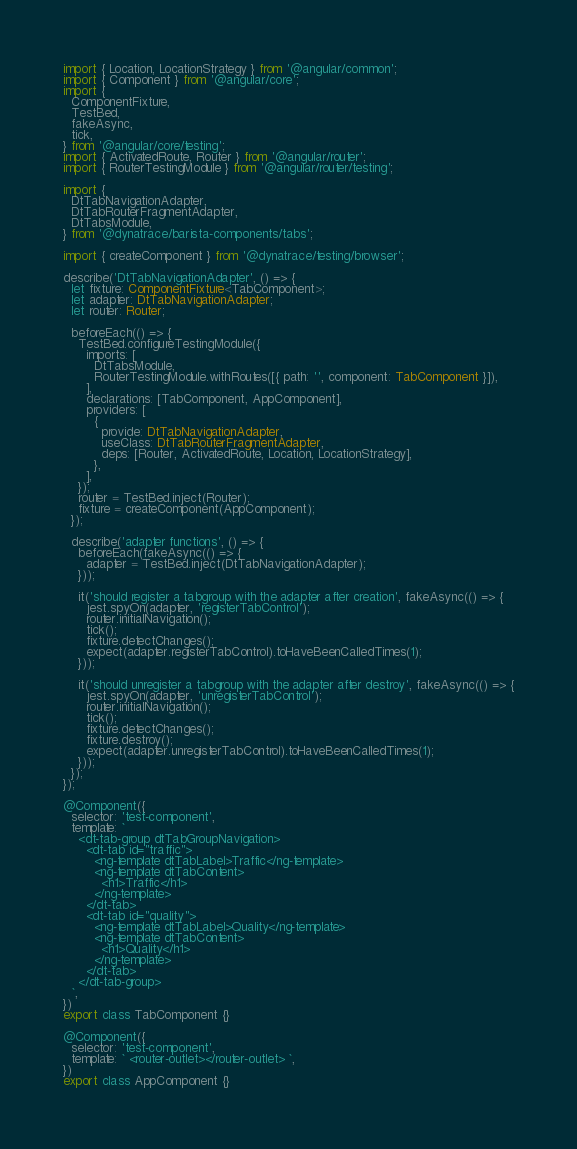<code> <loc_0><loc_0><loc_500><loc_500><_TypeScript_>import { Location, LocationStrategy } from '@angular/common';
import { Component } from '@angular/core';
import {
  ComponentFixture,
  TestBed,
  fakeAsync,
  tick,
} from '@angular/core/testing';
import { ActivatedRoute, Router } from '@angular/router';
import { RouterTestingModule } from '@angular/router/testing';

import {
  DtTabNavigationAdapter,
  DtTabRouterFragmentAdapter,
  DtTabsModule,
} from '@dynatrace/barista-components/tabs';

import { createComponent } from '@dynatrace/testing/browser';

describe('DtTabNavigationAdapter', () => {
  let fixture: ComponentFixture<TabComponent>;
  let adapter: DtTabNavigationAdapter;
  let router: Router;

  beforeEach(() => {
    TestBed.configureTestingModule({
      imports: [
        DtTabsModule,
        RouterTestingModule.withRoutes([{ path: '', component: TabComponent }]),
      ],
      declarations: [TabComponent, AppComponent],
      providers: [
        {
          provide: DtTabNavigationAdapter,
          useClass: DtTabRouterFragmentAdapter,
          deps: [Router, ActivatedRoute, Location, LocationStrategy],
        },
      ],
    });
    router = TestBed.inject(Router);
    fixture = createComponent(AppComponent);
  });

  describe('adapter functions', () => {
    beforeEach(fakeAsync(() => {
      adapter = TestBed.inject(DtTabNavigationAdapter);
    }));

    it('should register a tabgroup with the adapter after creation', fakeAsync(() => {
      jest.spyOn(adapter, 'registerTabControl');
      router.initialNavigation();
      tick();
      fixture.detectChanges();
      expect(adapter.registerTabControl).toHaveBeenCalledTimes(1);
    }));

    it('should unregister a tabgroup with the adapter after destroy', fakeAsync(() => {
      jest.spyOn(adapter, 'unregisterTabControl');
      router.initialNavigation();
      tick();
      fixture.detectChanges();
      fixture.destroy();
      expect(adapter.unregisterTabControl).toHaveBeenCalledTimes(1);
    }));
  });
});

@Component({
  selector: 'test-component',
  template: `
    <dt-tab-group dtTabGroupNavigation>
      <dt-tab id="traffic">
        <ng-template dtTabLabel>Traffic</ng-template>
        <ng-template dtTabContent>
          <h1>Traffic</h1>
        </ng-template>
      </dt-tab>
      <dt-tab id="quality">
        <ng-template dtTabLabel>Quality</ng-template>
        <ng-template dtTabContent>
          <h1>Quality</h1>
        </ng-template>
      </dt-tab>
    </dt-tab-group>
  `,
})
export class TabComponent {}

@Component({
  selector: 'test-component',
  template: ` <router-outlet></router-outlet> `,
})
export class AppComponent {}
</code> 